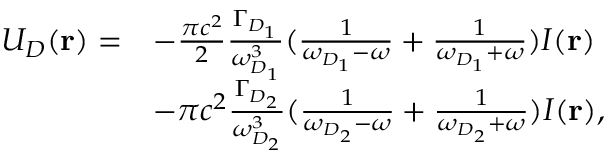Convert formula to latex. <formula><loc_0><loc_0><loc_500><loc_500>\begin{array} { r l } { U _ { D } ( r ) = } & { - \frac { \pi c ^ { 2 } } { 2 } \frac { \Gamma _ { D _ { 1 } } } { \omega _ { D _ { 1 } } ^ { 3 } } ( \frac { 1 } { \omega _ { D _ { 1 } } - \omega } + \frac { 1 } { \omega _ { D _ { 1 } } + \omega } ) I ( r ) } \\ & { - \pi c ^ { 2 } \frac { \Gamma _ { D _ { 2 } } } { \omega _ { D _ { 2 } } ^ { 3 } } ( \frac { 1 } { \omega _ { D _ { 2 } } - \omega } + \frac { 1 } { \omega _ { D _ { 2 } } + \omega } ) I ( r ) , } \end{array}</formula> 